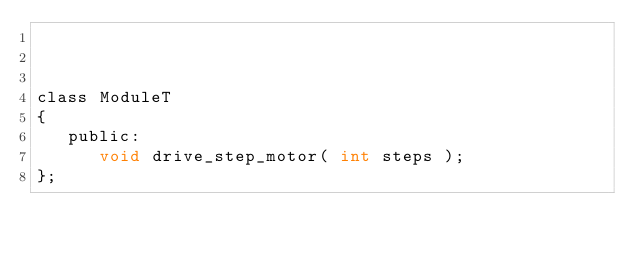<code> <loc_0><loc_0><loc_500><loc_500><_C_>


class ModuleT
{
   public:
      void drive_step_motor( int steps );
};
</code> 